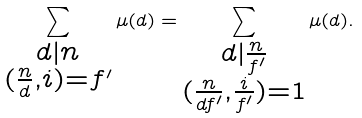Convert formula to latex. <formula><loc_0><loc_0><loc_500><loc_500>\sum _ { \substack { d | n \\ ( \frac { n } { d } , i ) = f ^ { \prime } } } \mu ( d ) = \sum _ { \substack { d | \frac { n } { f ^ { \prime } } \\ ( \frac { n } { d f ^ { \prime } } , \frac { i } { f ^ { \prime } } ) = 1 } } \mu ( d ) .</formula> 